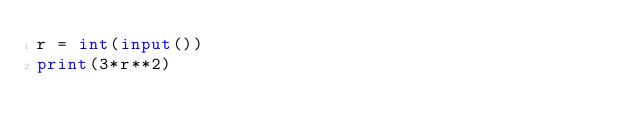<code> <loc_0><loc_0><loc_500><loc_500><_Python_>r = int(input())
print(3*r**2)</code> 